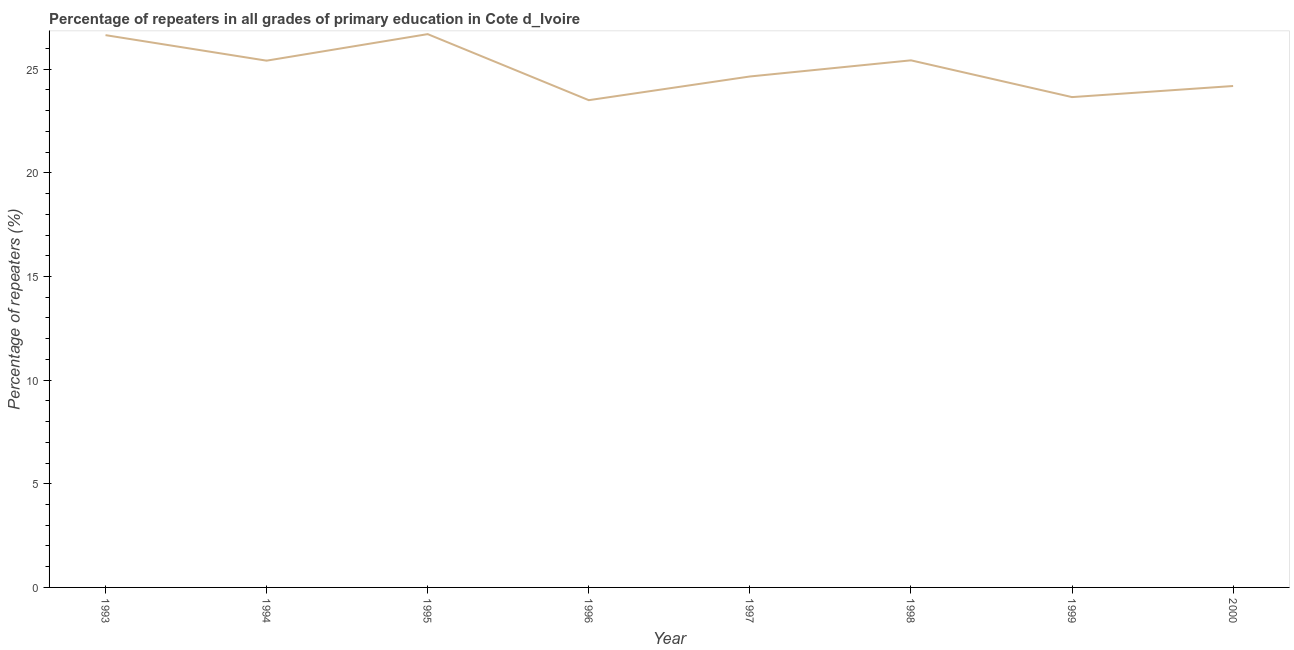What is the percentage of repeaters in primary education in 1998?
Make the answer very short. 25.43. Across all years, what is the maximum percentage of repeaters in primary education?
Make the answer very short. 26.69. Across all years, what is the minimum percentage of repeaters in primary education?
Your answer should be compact. 23.5. In which year was the percentage of repeaters in primary education maximum?
Provide a short and direct response. 1995. In which year was the percentage of repeaters in primary education minimum?
Keep it short and to the point. 1996. What is the sum of the percentage of repeaters in primary education?
Ensure brevity in your answer.  200.16. What is the difference between the percentage of repeaters in primary education in 1994 and 1997?
Your answer should be very brief. 0.76. What is the average percentage of repeaters in primary education per year?
Offer a terse response. 25.02. What is the median percentage of repeaters in primary education?
Offer a terse response. 25.03. What is the ratio of the percentage of repeaters in primary education in 1995 to that in 1996?
Provide a short and direct response. 1.14. Is the percentage of repeaters in primary education in 1998 less than that in 1999?
Make the answer very short. No. What is the difference between the highest and the second highest percentage of repeaters in primary education?
Offer a very short reply. 0.05. Is the sum of the percentage of repeaters in primary education in 1995 and 1997 greater than the maximum percentage of repeaters in primary education across all years?
Your answer should be very brief. Yes. What is the difference between the highest and the lowest percentage of repeaters in primary education?
Keep it short and to the point. 3.19. Are the values on the major ticks of Y-axis written in scientific E-notation?
Offer a terse response. No. What is the title of the graph?
Offer a terse response. Percentage of repeaters in all grades of primary education in Cote d_Ivoire. What is the label or title of the X-axis?
Your answer should be compact. Year. What is the label or title of the Y-axis?
Offer a terse response. Percentage of repeaters (%). What is the Percentage of repeaters (%) of 1993?
Your response must be concise. 26.64. What is the Percentage of repeaters (%) of 1994?
Your answer should be compact. 25.41. What is the Percentage of repeaters (%) of 1995?
Provide a succinct answer. 26.69. What is the Percentage of repeaters (%) of 1996?
Give a very brief answer. 23.5. What is the Percentage of repeaters (%) of 1997?
Offer a very short reply. 24.65. What is the Percentage of repeaters (%) of 1998?
Your answer should be compact. 25.43. What is the Percentage of repeaters (%) of 1999?
Offer a very short reply. 23.65. What is the Percentage of repeaters (%) in 2000?
Make the answer very short. 24.19. What is the difference between the Percentage of repeaters (%) in 1993 and 1994?
Provide a succinct answer. 1.23. What is the difference between the Percentage of repeaters (%) in 1993 and 1995?
Offer a very short reply. -0.05. What is the difference between the Percentage of repeaters (%) in 1993 and 1996?
Offer a terse response. 3.14. What is the difference between the Percentage of repeaters (%) in 1993 and 1997?
Provide a succinct answer. 1.99. What is the difference between the Percentage of repeaters (%) in 1993 and 1998?
Provide a succinct answer. 1.22. What is the difference between the Percentage of repeaters (%) in 1993 and 1999?
Provide a short and direct response. 2.99. What is the difference between the Percentage of repeaters (%) in 1993 and 2000?
Keep it short and to the point. 2.45. What is the difference between the Percentage of repeaters (%) in 1994 and 1995?
Offer a terse response. -1.28. What is the difference between the Percentage of repeaters (%) in 1994 and 1996?
Give a very brief answer. 1.91. What is the difference between the Percentage of repeaters (%) in 1994 and 1997?
Your answer should be compact. 0.76. What is the difference between the Percentage of repeaters (%) in 1994 and 1998?
Provide a succinct answer. -0.02. What is the difference between the Percentage of repeaters (%) in 1994 and 1999?
Provide a short and direct response. 1.76. What is the difference between the Percentage of repeaters (%) in 1994 and 2000?
Make the answer very short. 1.22. What is the difference between the Percentage of repeaters (%) in 1995 and 1996?
Provide a short and direct response. 3.19. What is the difference between the Percentage of repeaters (%) in 1995 and 1997?
Your answer should be compact. 2.04. What is the difference between the Percentage of repeaters (%) in 1995 and 1998?
Ensure brevity in your answer.  1.26. What is the difference between the Percentage of repeaters (%) in 1995 and 1999?
Make the answer very short. 3.04. What is the difference between the Percentage of repeaters (%) in 1995 and 2000?
Give a very brief answer. 2.5. What is the difference between the Percentage of repeaters (%) in 1996 and 1997?
Ensure brevity in your answer.  -1.14. What is the difference between the Percentage of repeaters (%) in 1996 and 1998?
Ensure brevity in your answer.  -1.92. What is the difference between the Percentage of repeaters (%) in 1996 and 1999?
Keep it short and to the point. -0.15. What is the difference between the Percentage of repeaters (%) in 1996 and 2000?
Your response must be concise. -0.68. What is the difference between the Percentage of repeaters (%) in 1997 and 1998?
Keep it short and to the point. -0.78. What is the difference between the Percentage of repeaters (%) in 1997 and 1999?
Provide a short and direct response. 0.99. What is the difference between the Percentage of repeaters (%) in 1997 and 2000?
Your answer should be compact. 0.46. What is the difference between the Percentage of repeaters (%) in 1998 and 1999?
Your response must be concise. 1.77. What is the difference between the Percentage of repeaters (%) in 1998 and 2000?
Your answer should be compact. 1.24. What is the difference between the Percentage of repeaters (%) in 1999 and 2000?
Your answer should be very brief. -0.54. What is the ratio of the Percentage of repeaters (%) in 1993 to that in 1994?
Keep it short and to the point. 1.05. What is the ratio of the Percentage of repeaters (%) in 1993 to that in 1996?
Offer a terse response. 1.13. What is the ratio of the Percentage of repeaters (%) in 1993 to that in 1997?
Offer a terse response. 1.08. What is the ratio of the Percentage of repeaters (%) in 1993 to that in 1998?
Make the answer very short. 1.05. What is the ratio of the Percentage of repeaters (%) in 1993 to that in 1999?
Offer a terse response. 1.13. What is the ratio of the Percentage of repeaters (%) in 1993 to that in 2000?
Your response must be concise. 1.1. What is the ratio of the Percentage of repeaters (%) in 1994 to that in 1996?
Provide a succinct answer. 1.08. What is the ratio of the Percentage of repeaters (%) in 1994 to that in 1997?
Offer a terse response. 1.03. What is the ratio of the Percentage of repeaters (%) in 1994 to that in 1998?
Your response must be concise. 1. What is the ratio of the Percentage of repeaters (%) in 1994 to that in 1999?
Offer a terse response. 1.07. What is the ratio of the Percentage of repeaters (%) in 1994 to that in 2000?
Your answer should be compact. 1.05. What is the ratio of the Percentage of repeaters (%) in 1995 to that in 1996?
Give a very brief answer. 1.14. What is the ratio of the Percentage of repeaters (%) in 1995 to that in 1997?
Provide a succinct answer. 1.08. What is the ratio of the Percentage of repeaters (%) in 1995 to that in 1998?
Your answer should be compact. 1.05. What is the ratio of the Percentage of repeaters (%) in 1995 to that in 1999?
Keep it short and to the point. 1.13. What is the ratio of the Percentage of repeaters (%) in 1995 to that in 2000?
Offer a terse response. 1.1. What is the ratio of the Percentage of repeaters (%) in 1996 to that in 1997?
Your answer should be compact. 0.95. What is the ratio of the Percentage of repeaters (%) in 1996 to that in 1998?
Keep it short and to the point. 0.92. What is the ratio of the Percentage of repeaters (%) in 1996 to that in 2000?
Provide a succinct answer. 0.97. What is the ratio of the Percentage of repeaters (%) in 1997 to that in 1999?
Your response must be concise. 1.04. What is the ratio of the Percentage of repeaters (%) in 1998 to that in 1999?
Your response must be concise. 1.07. What is the ratio of the Percentage of repeaters (%) in 1998 to that in 2000?
Your answer should be compact. 1.05. 